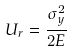<formula> <loc_0><loc_0><loc_500><loc_500>U _ { r } = \frac { \sigma _ { y } ^ { 2 } } { 2 E }</formula> 